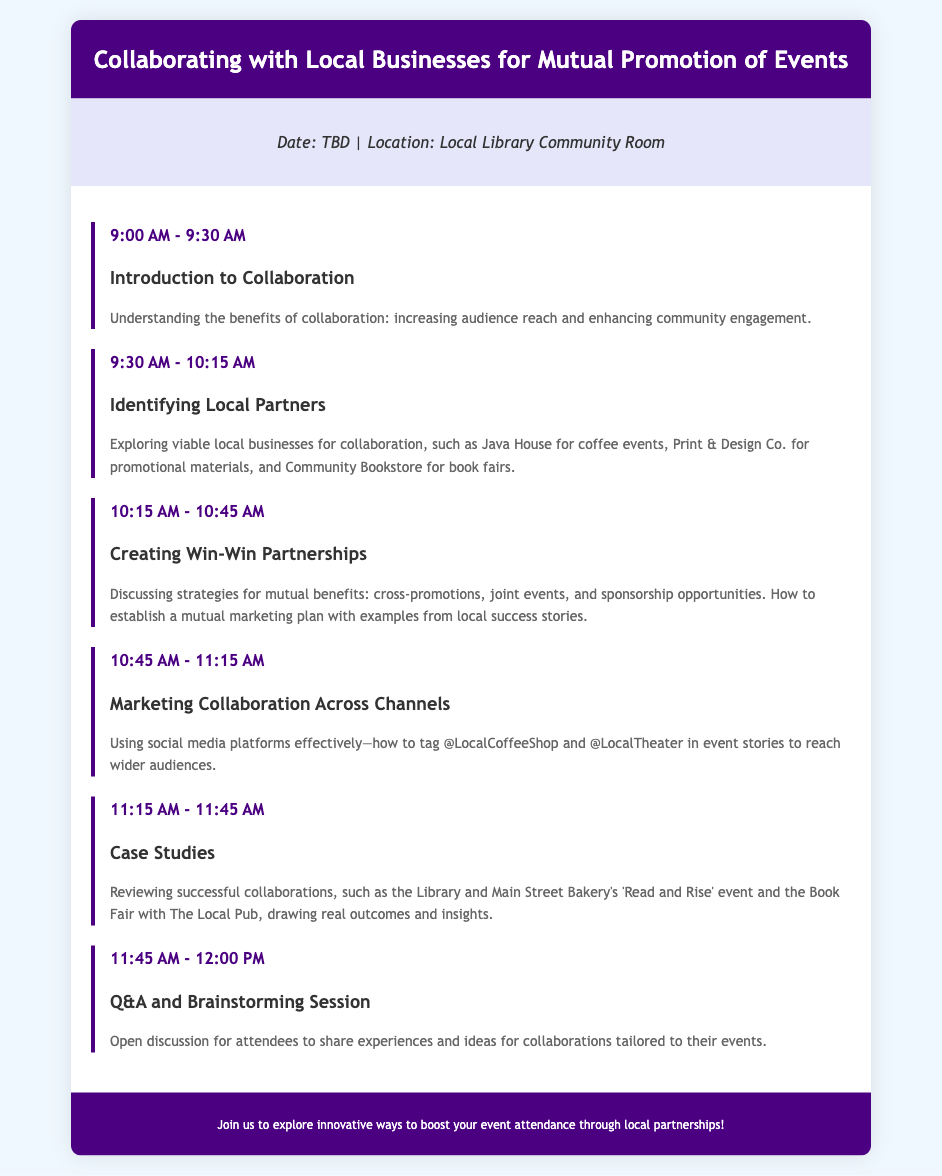what is the event title? The event title is prominently displayed at the top of the document.
Answer: Collaborating with Local Businesses for Mutual Promotion of Events what time does the event start? The start time is indicated in the agenda section of the document.
Answer: 9:00 AM who is the first presenter in the agenda? The first topic listed in the agenda indicates the first presenter.
Answer: Introduction to Collaboration how long is the Q&A session? The duration of the Q&A session is detailed in the agenda under its time slot.
Answer: 15 minutes what are two examples of local partners mentioned? The document provides examples of local partners in the second agenda item.
Answer: Java House, Community Bookstore what is one strategy discussed for establishing partnerships? The document mentions topics to be discussed, indicating strategies for partnerships.
Answer: cross-promotions which social media platforms are suggested for marketing collaboration? Specific platforms are referenced in the agenda about marketing collaboration.
Answer: social media what is the purpose of the case studies section? The purpose is outlined in the description of the respective agenda item.
Answer: reviewing successful collaborations how long is the entire event scheduled to last? The total time can be calculated based on the starting time and the last agenda item.
Answer: 3 hours 